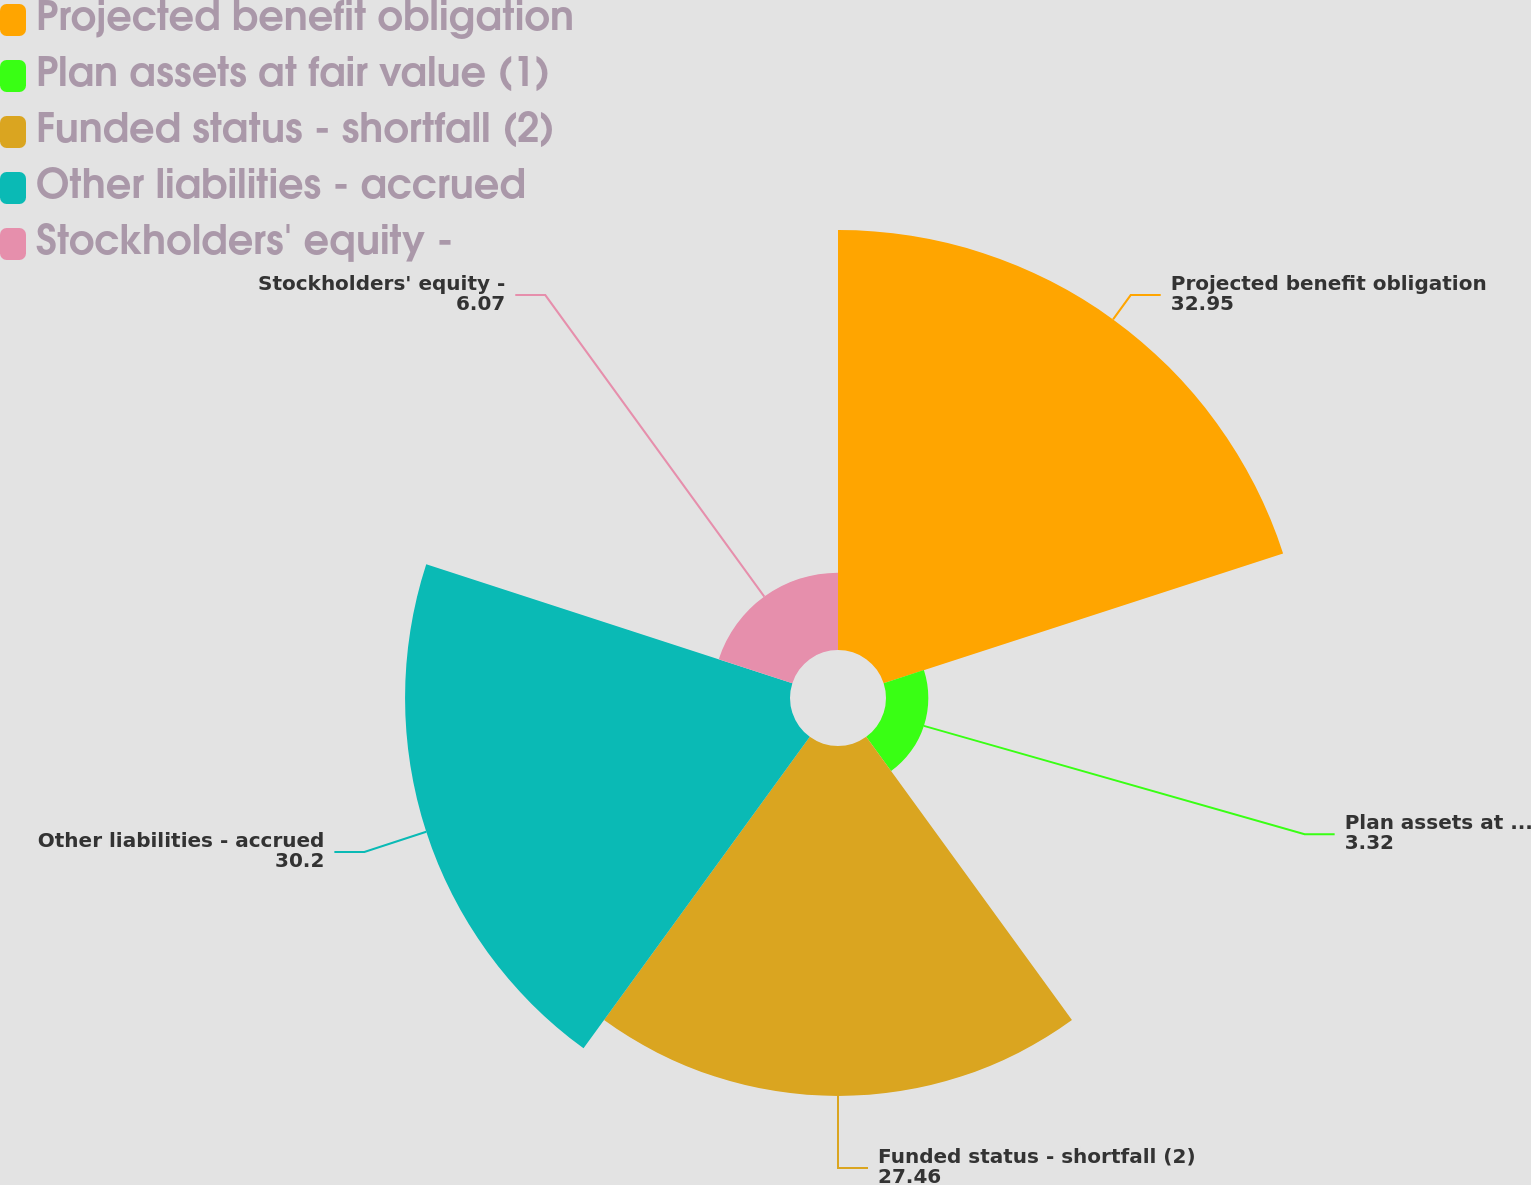Convert chart. <chart><loc_0><loc_0><loc_500><loc_500><pie_chart><fcel>Projected benefit obligation<fcel>Plan assets at fair value (1)<fcel>Funded status - shortfall (2)<fcel>Other liabilities - accrued<fcel>Stockholders' equity -<nl><fcel>32.95%<fcel>3.32%<fcel>27.46%<fcel>30.2%<fcel>6.07%<nl></chart> 